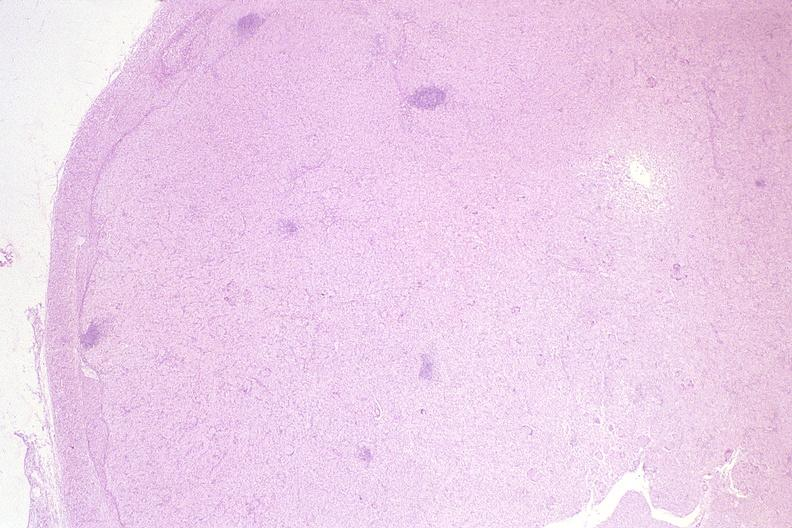does this image show lymph node, mycobacterium avium-intracellularae?
Answer the question using a single word or phrase. Yes 